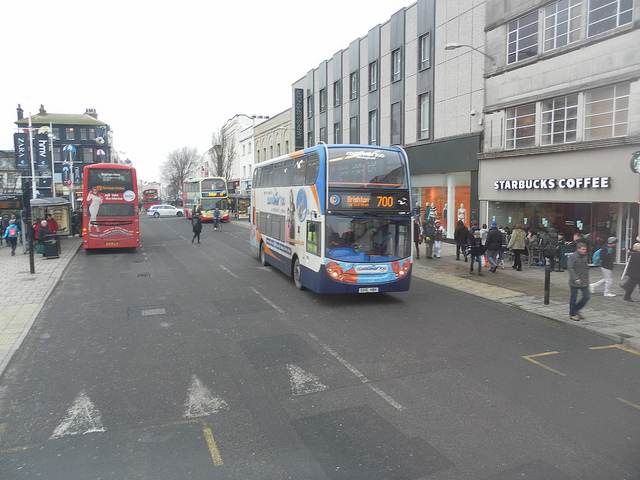Imagine you are planning a festive event here. What kind of decorations and activities would you suggest? To transform this bustling urban street into a festive event space, I'd suggest a mix of vibrant and engaging decorations and activities. String lights and festive banners could be hung between the streetlights and along the buildings to create a welcoming ambiance. Temporary stalls and food trucks, including one from Starbucks, could be set up, serving a variety of winter treats and warm beverages. Street performers, including musicians and magicians, could entertain the crowds, adding to the lively atmosphere. A small stage could be erected for local bands or choirs, bringing music to the event. For children, a mini funfair with games and rides could be organized, ensuring there's something fun for everyone. 